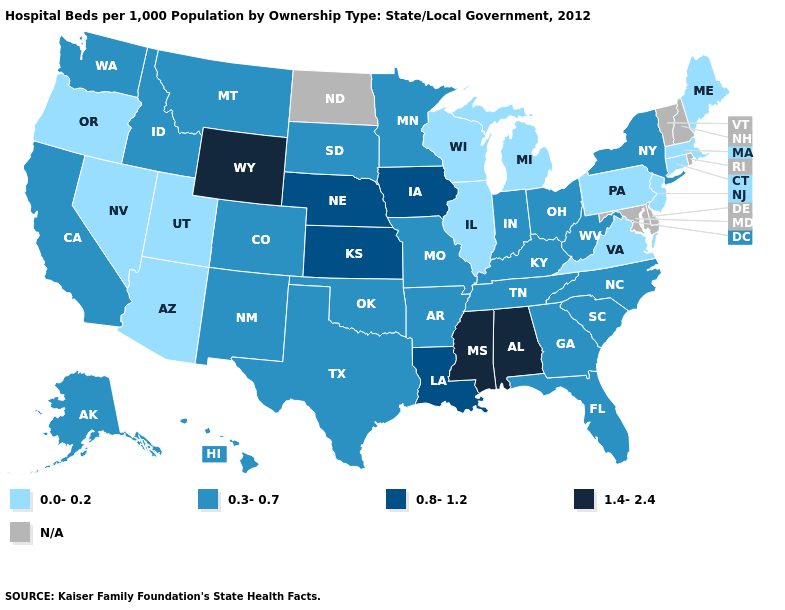Is the legend a continuous bar?
Keep it brief. No. What is the value of Pennsylvania?
Be succinct. 0.0-0.2. Which states have the lowest value in the USA?
Concise answer only. Arizona, Connecticut, Illinois, Maine, Massachusetts, Michigan, Nevada, New Jersey, Oregon, Pennsylvania, Utah, Virginia, Wisconsin. Does South Dakota have the lowest value in the MidWest?
Answer briefly. No. What is the lowest value in the USA?
Write a very short answer. 0.0-0.2. Name the states that have a value in the range N/A?
Write a very short answer. Delaware, Maryland, New Hampshire, North Dakota, Rhode Island, Vermont. Name the states that have a value in the range 0.0-0.2?
Write a very short answer. Arizona, Connecticut, Illinois, Maine, Massachusetts, Michigan, Nevada, New Jersey, Oregon, Pennsylvania, Utah, Virginia, Wisconsin. What is the lowest value in the South?
Write a very short answer. 0.0-0.2. Does Wisconsin have the highest value in the MidWest?
Short answer required. No. What is the value of Iowa?
Be succinct. 0.8-1.2. What is the value of Nebraska?
Be succinct. 0.8-1.2. What is the highest value in states that border Wisconsin?
Be succinct. 0.8-1.2. What is the value of Maryland?
Quick response, please. N/A. Which states have the highest value in the USA?
Concise answer only. Alabama, Mississippi, Wyoming. What is the highest value in the USA?
Answer briefly. 1.4-2.4. 